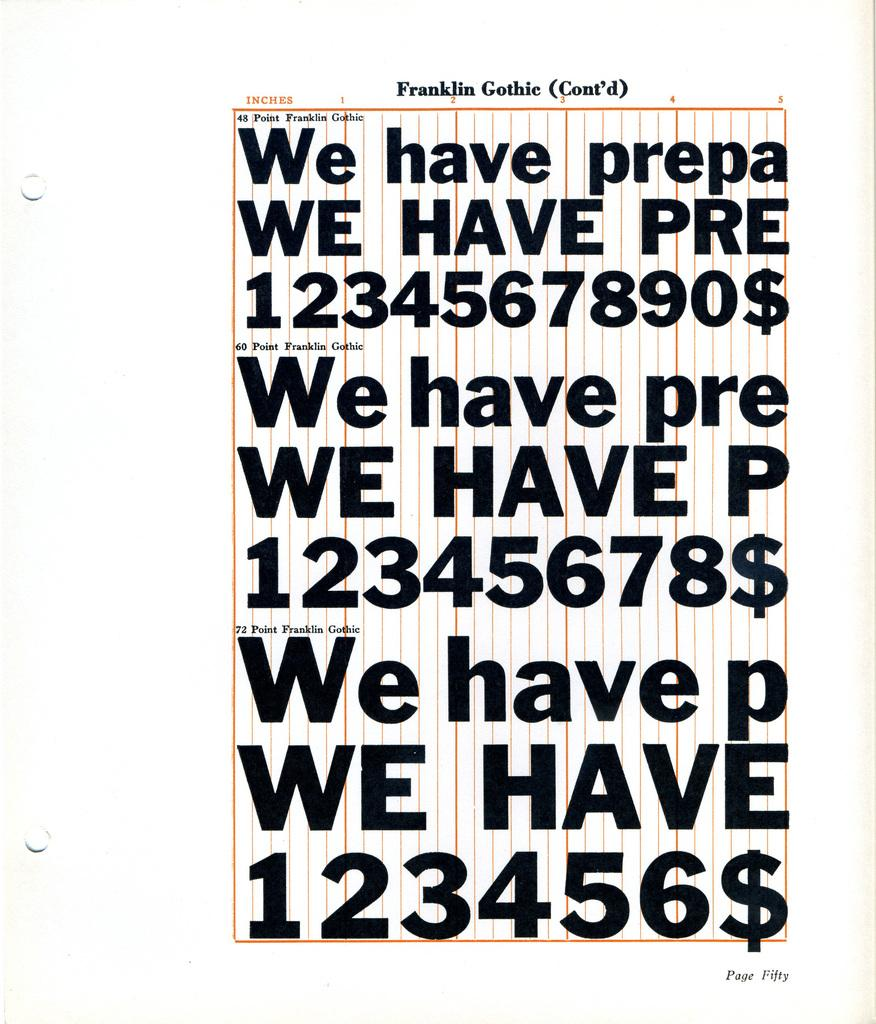<image>
Relay a brief, clear account of the picture shown. a paper with repeating 1234 numbers on it 